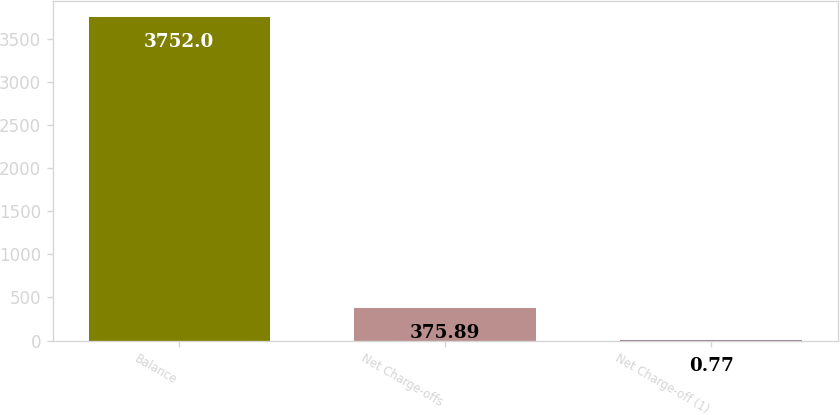Convert chart to OTSL. <chart><loc_0><loc_0><loc_500><loc_500><bar_chart><fcel>Balance<fcel>Net Charge-offs<fcel>Net Charge-off (1)<nl><fcel>3752<fcel>375.89<fcel>0.77<nl></chart> 